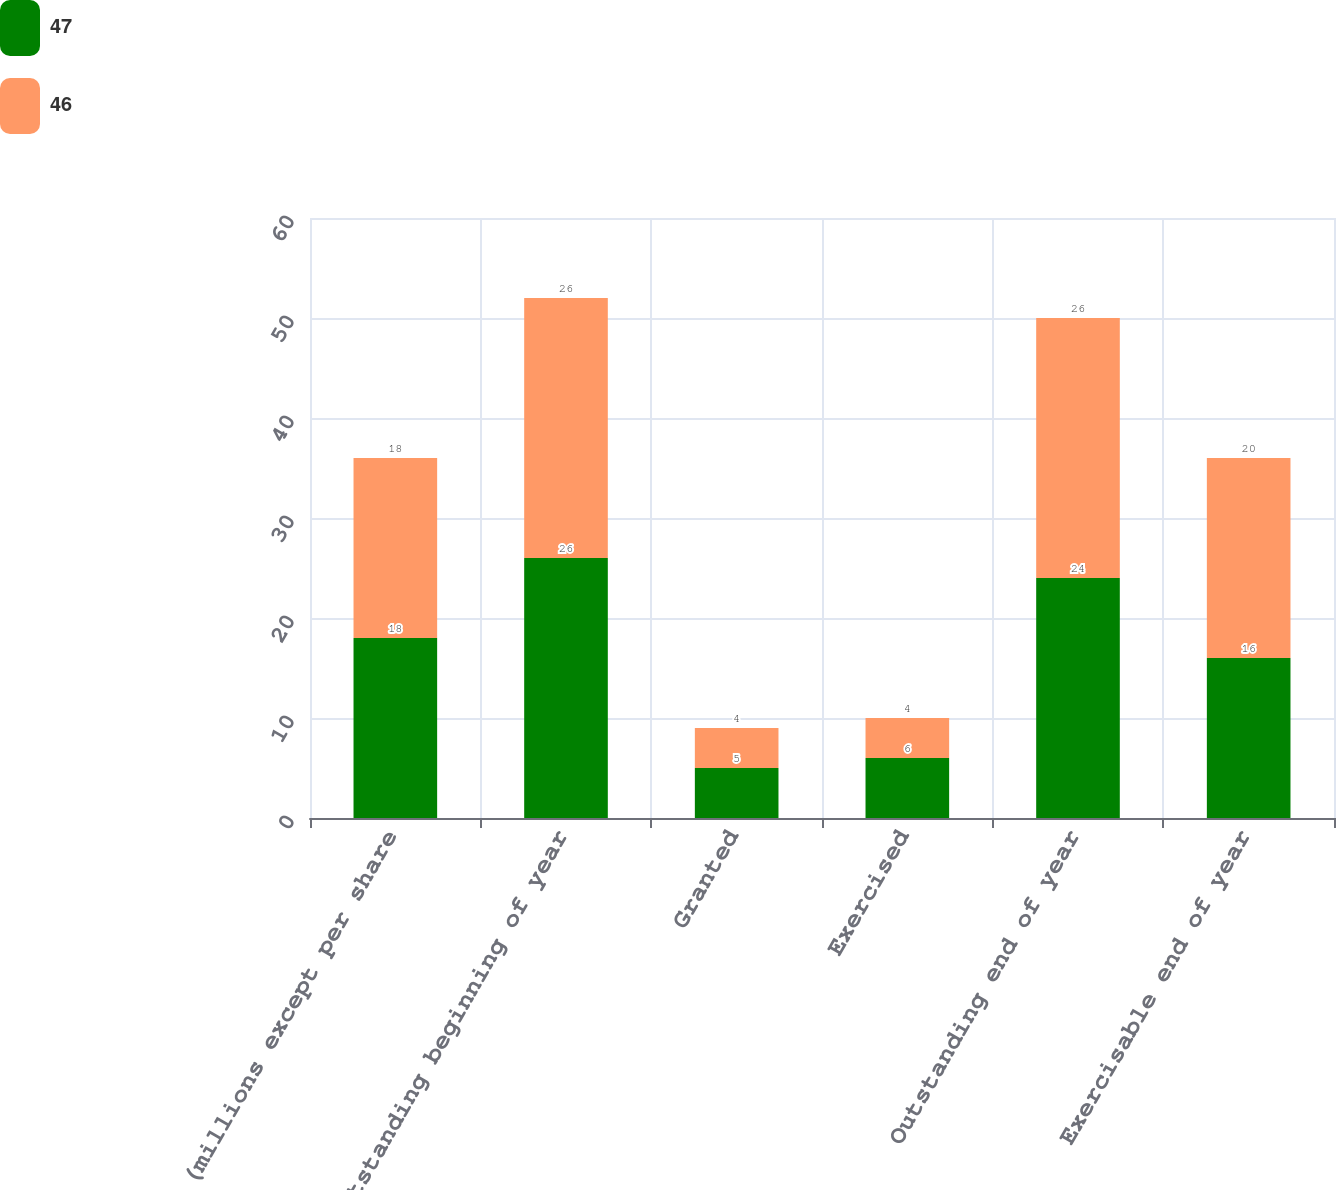Convert chart to OTSL. <chart><loc_0><loc_0><loc_500><loc_500><stacked_bar_chart><ecel><fcel>(millions except per share<fcel>Outstanding beginning of year<fcel>Granted<fcel>Exercised<fcel>Outstanding end of year<fcel>Exercisable end of year<nl><fcel>47<fcel>18<fcel>26<fcel>5<fcel>6<fcel>24<fcel>16<nl><fcel>46<fcel>18<fcel>26<fcel>4<fcel>4<fcel>26<fcel>20<nl></chart> 